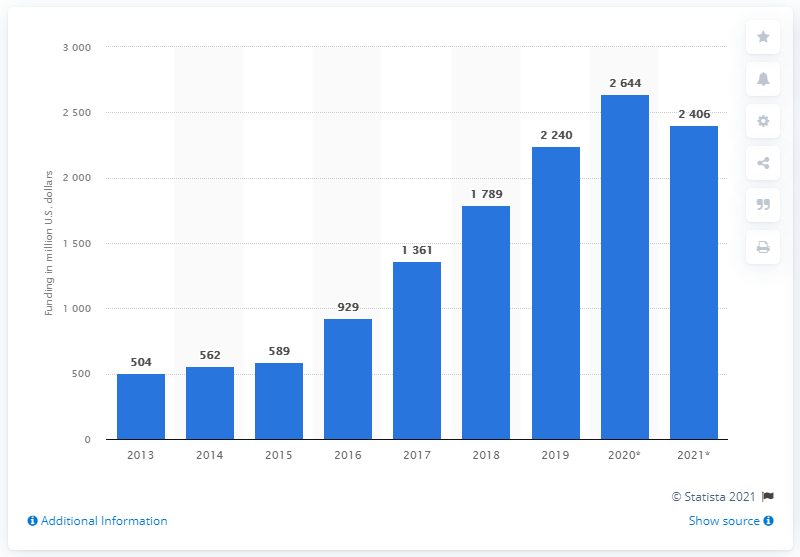Give some essential details in this illustration. In the fiscal year 2019, the National Institutes of Health (NIH) provided funding for Alzheimer's disease research totaling 2240. 